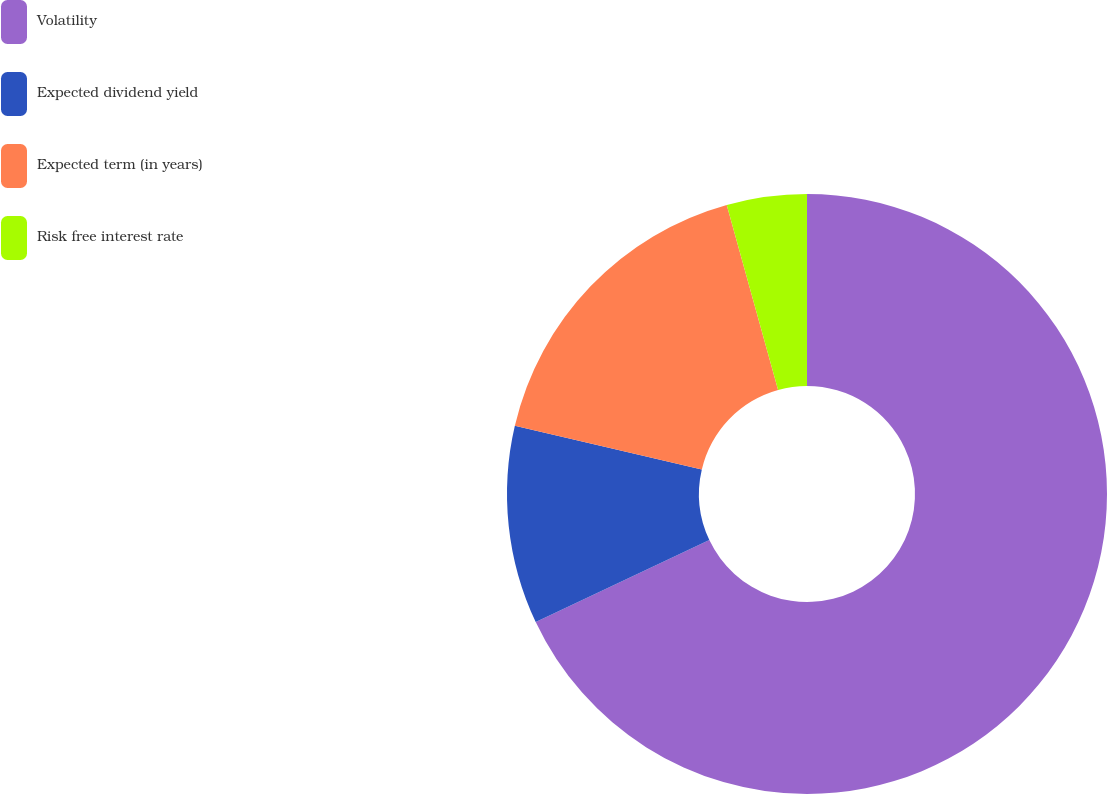<chart> <loc_0><loc_0><loc_500><loc_500><pie_chart><fcel>Volatility<fcel>Expected dividend yield<fcel>Expected term (in years)<fcel>Risk free interest rate<nl><fcel>67.98%<fcel>10.67%<fcel>17.04%<fcel>4.31%<nl></chart> 